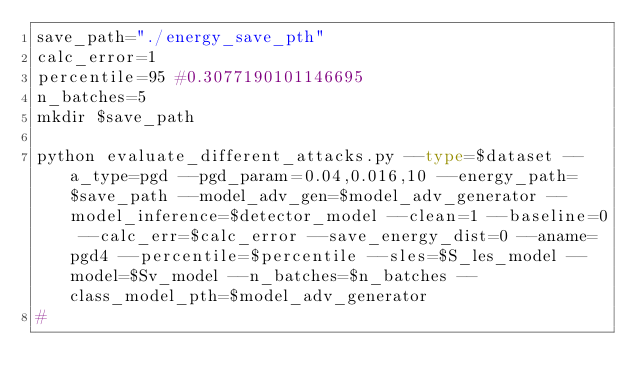<code> <loc_0><loc_0><loc_500><loc_500><_Bash_>save_path="./energy_save_pth"
calc_error=1
percentile=95 #0.3077190101146695
n_batches=5
mkdir $save_path

python evaluate_different_attacks.py --type=$dataset --a_type=pgd --pgd_param=0.04,0.016,10 --energy_path=$save_path --model_adv_gen=$model_adv_generator --model_inference=$detector_model --clean=1 --baseline=0 --calc_err=$calc_error --save_energy_dist=0 --aname=pgd4 --percentile=$percentile --sles=$S_les_model --model=$Sv_model --n_batches=$n_batches --class_model_pth=$model_adv_generator
#</code> 